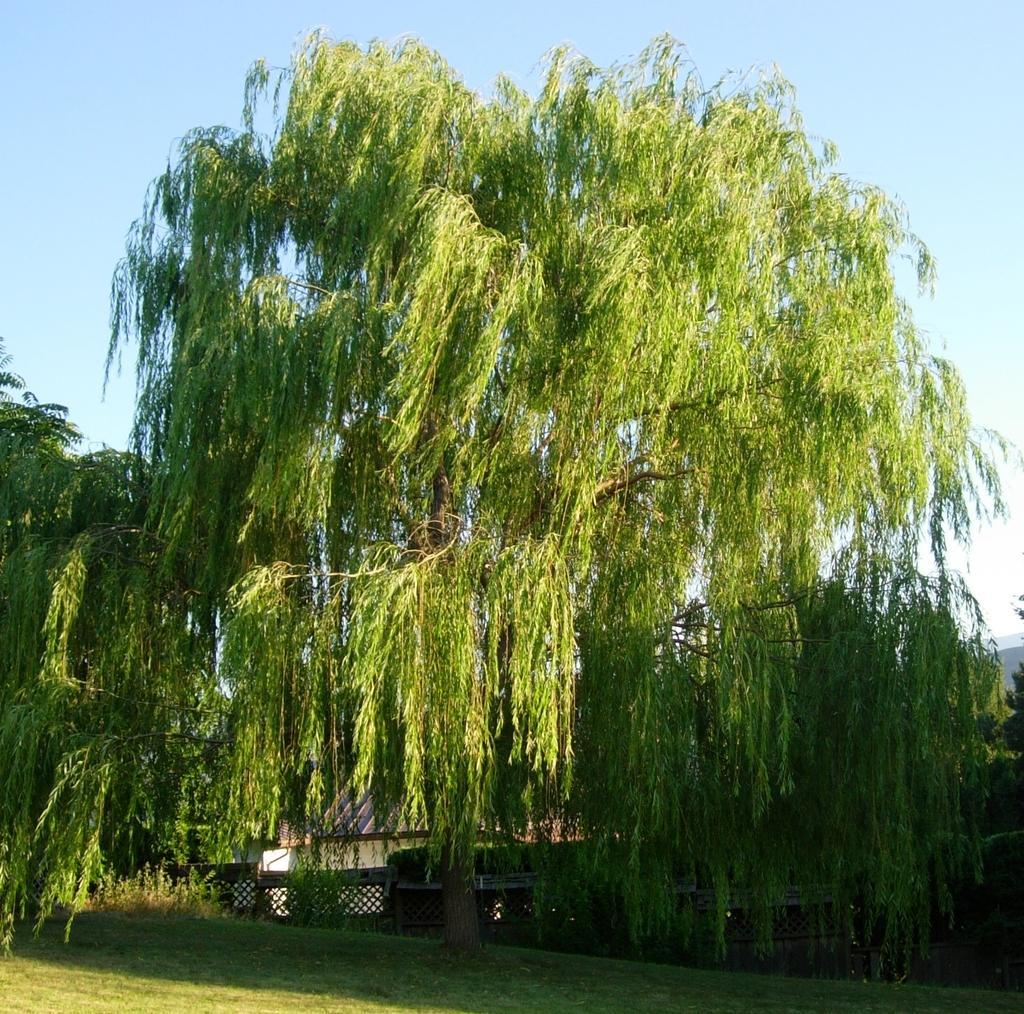In one or two sentences, can you explain what this image depicts? In this image we can see group of trees ,buildings and in the background, we can see the sky. 